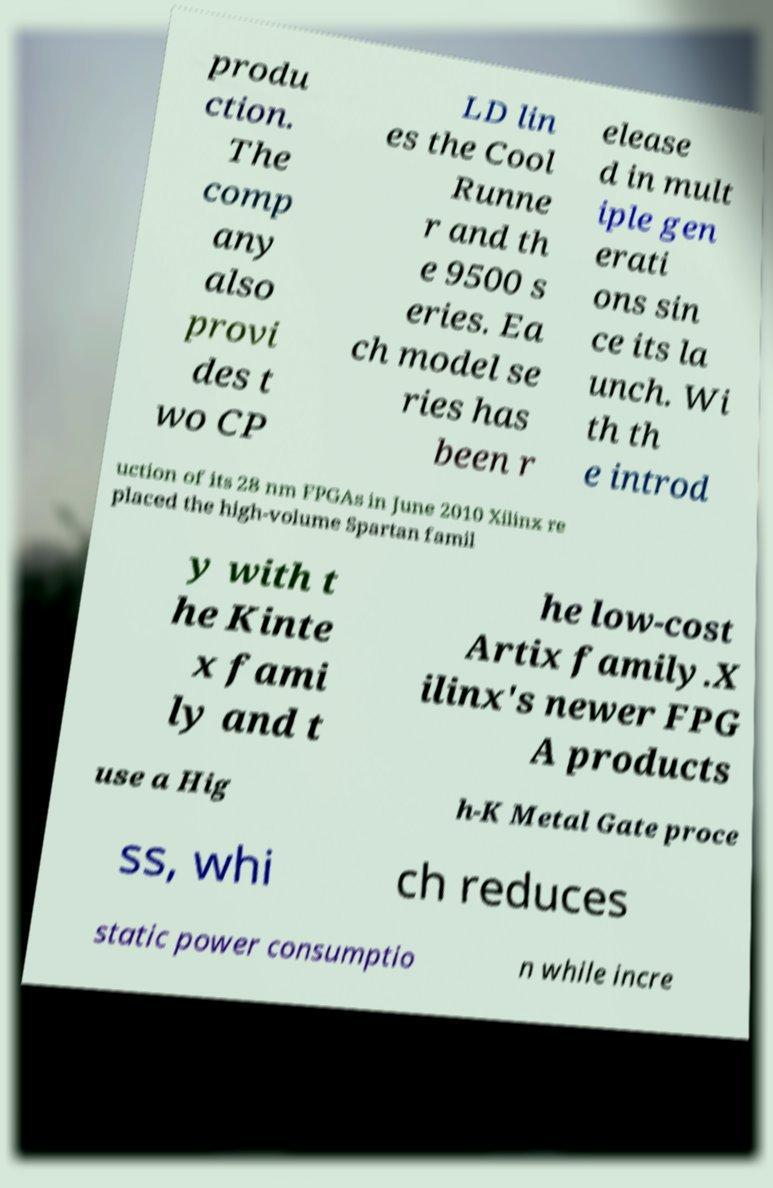Could you extract and type out the text from this image? produ ction. The comp any also provi des t wo CP LD lin es the Cool Runne r and th e 9500 s eries. Ea ch model se ries has been r elease d in mult iple gen erati ons sin ce its la unch. Wi th th e introd uction of its 28 nm FPGAs in June 2010 Xilinx re placed the high-volume Spartan famil y with t he Kinte x fami ly and t he low-cost Artix family.X ilinx's newer FPG A products use a Hig h-K Metal Gate proce ss, whi ch reduces static power consumptio n while incre 